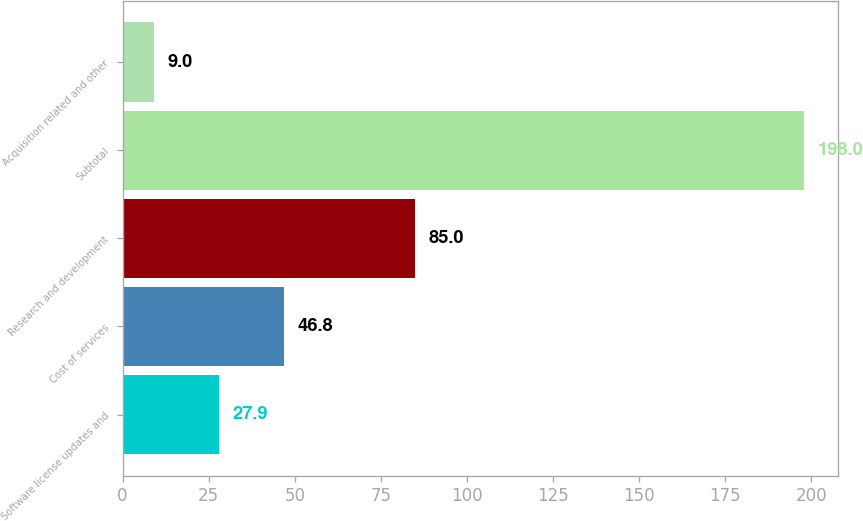Convert chart. <chart><loc_0><loc_0><loc_500><loc_500><bar_chart><fcel>Software license updates and<fcel>Cost of services<fcel>Research and development<fcel>Subtotal<fcel>Acquisition related and other<nl><fcel>27.9<fcel>46.8<fcel>85<fcel>198<fcel>9<nl></chart> 